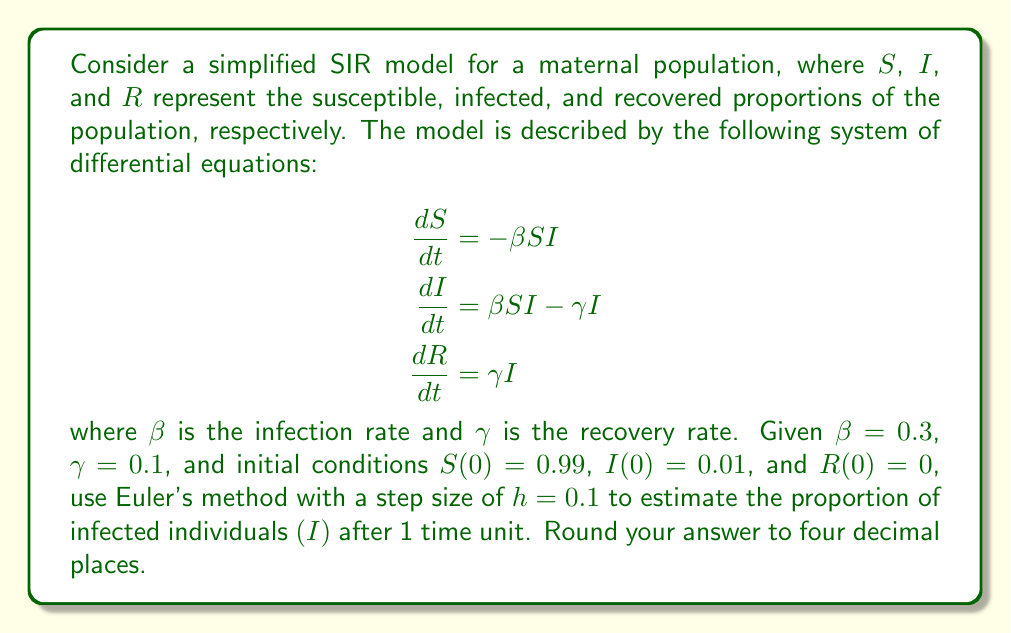Solve this math problem. To solve this problem using Euler's method, we'll follow these steps:

1) Euler's method for a system of differential equations is given by:
   $$y_{n+1} = y_n + h f(t_n, y_n)$$
   where $h$ is the step size and $f(t_n, y_n)$ is the right-hand side of the differential equation.

2) For our system, we have:
   $$\begin{aligned}
   S_{n+1} &= S_n + h(-\beta S_n I_n) \\
   I_{n+1} &= I_n + h(\beta S_n I_n - \gamma I_n) \\
   R_{n+1} &= R_n + h(\gamma I_n)
   \end{aligned}$$

3) Given values:
   $\beta = 0.3$, $\gamma = 0.1$, $h = 0.1$
   $S_0 = 0.99$, $I_0 = 0.01$, $R_0 = 0$

4) We need to iterate 10 times to reach t = 1 (since $h = 0.1$ and we want to go from $t = 0$ to $t = 1$).

5) First iteration:
   $$\begin{aligned}
   S_1 &= 0.99 + 0.1(-0.3 \cdot 0.99 \cdot 0.01) = 0.9897 \\
   I_1 &= 0.01 + 0.1(0.3 \cdot 0.99 \cdot 0.01 - 0.1 \cdot 0.01) = 0.0102 \\
   R_1 &= 0 + 0.1(0.1 \cdot 0.01) = 0.0001
   \end{aligned}$$

6) We continue this process for 9 more iterations. The results for $I$ at each step are:
   $I_2 = 0.0104$, $I_3 = 0.0106$, $I_4 = 0.0108$, $I_5 = 0.0110$
   $I_6 = 0.0112$, $I_7 = 0.0114$, $I_8 = 0.0116$, $I_9 = 0.0118$
   $I_{10} = 0.0120$

7) Therefore, after 1 time unit, the estimated proportion of infected individuals is 0.0120.
Answer: 0.0120 